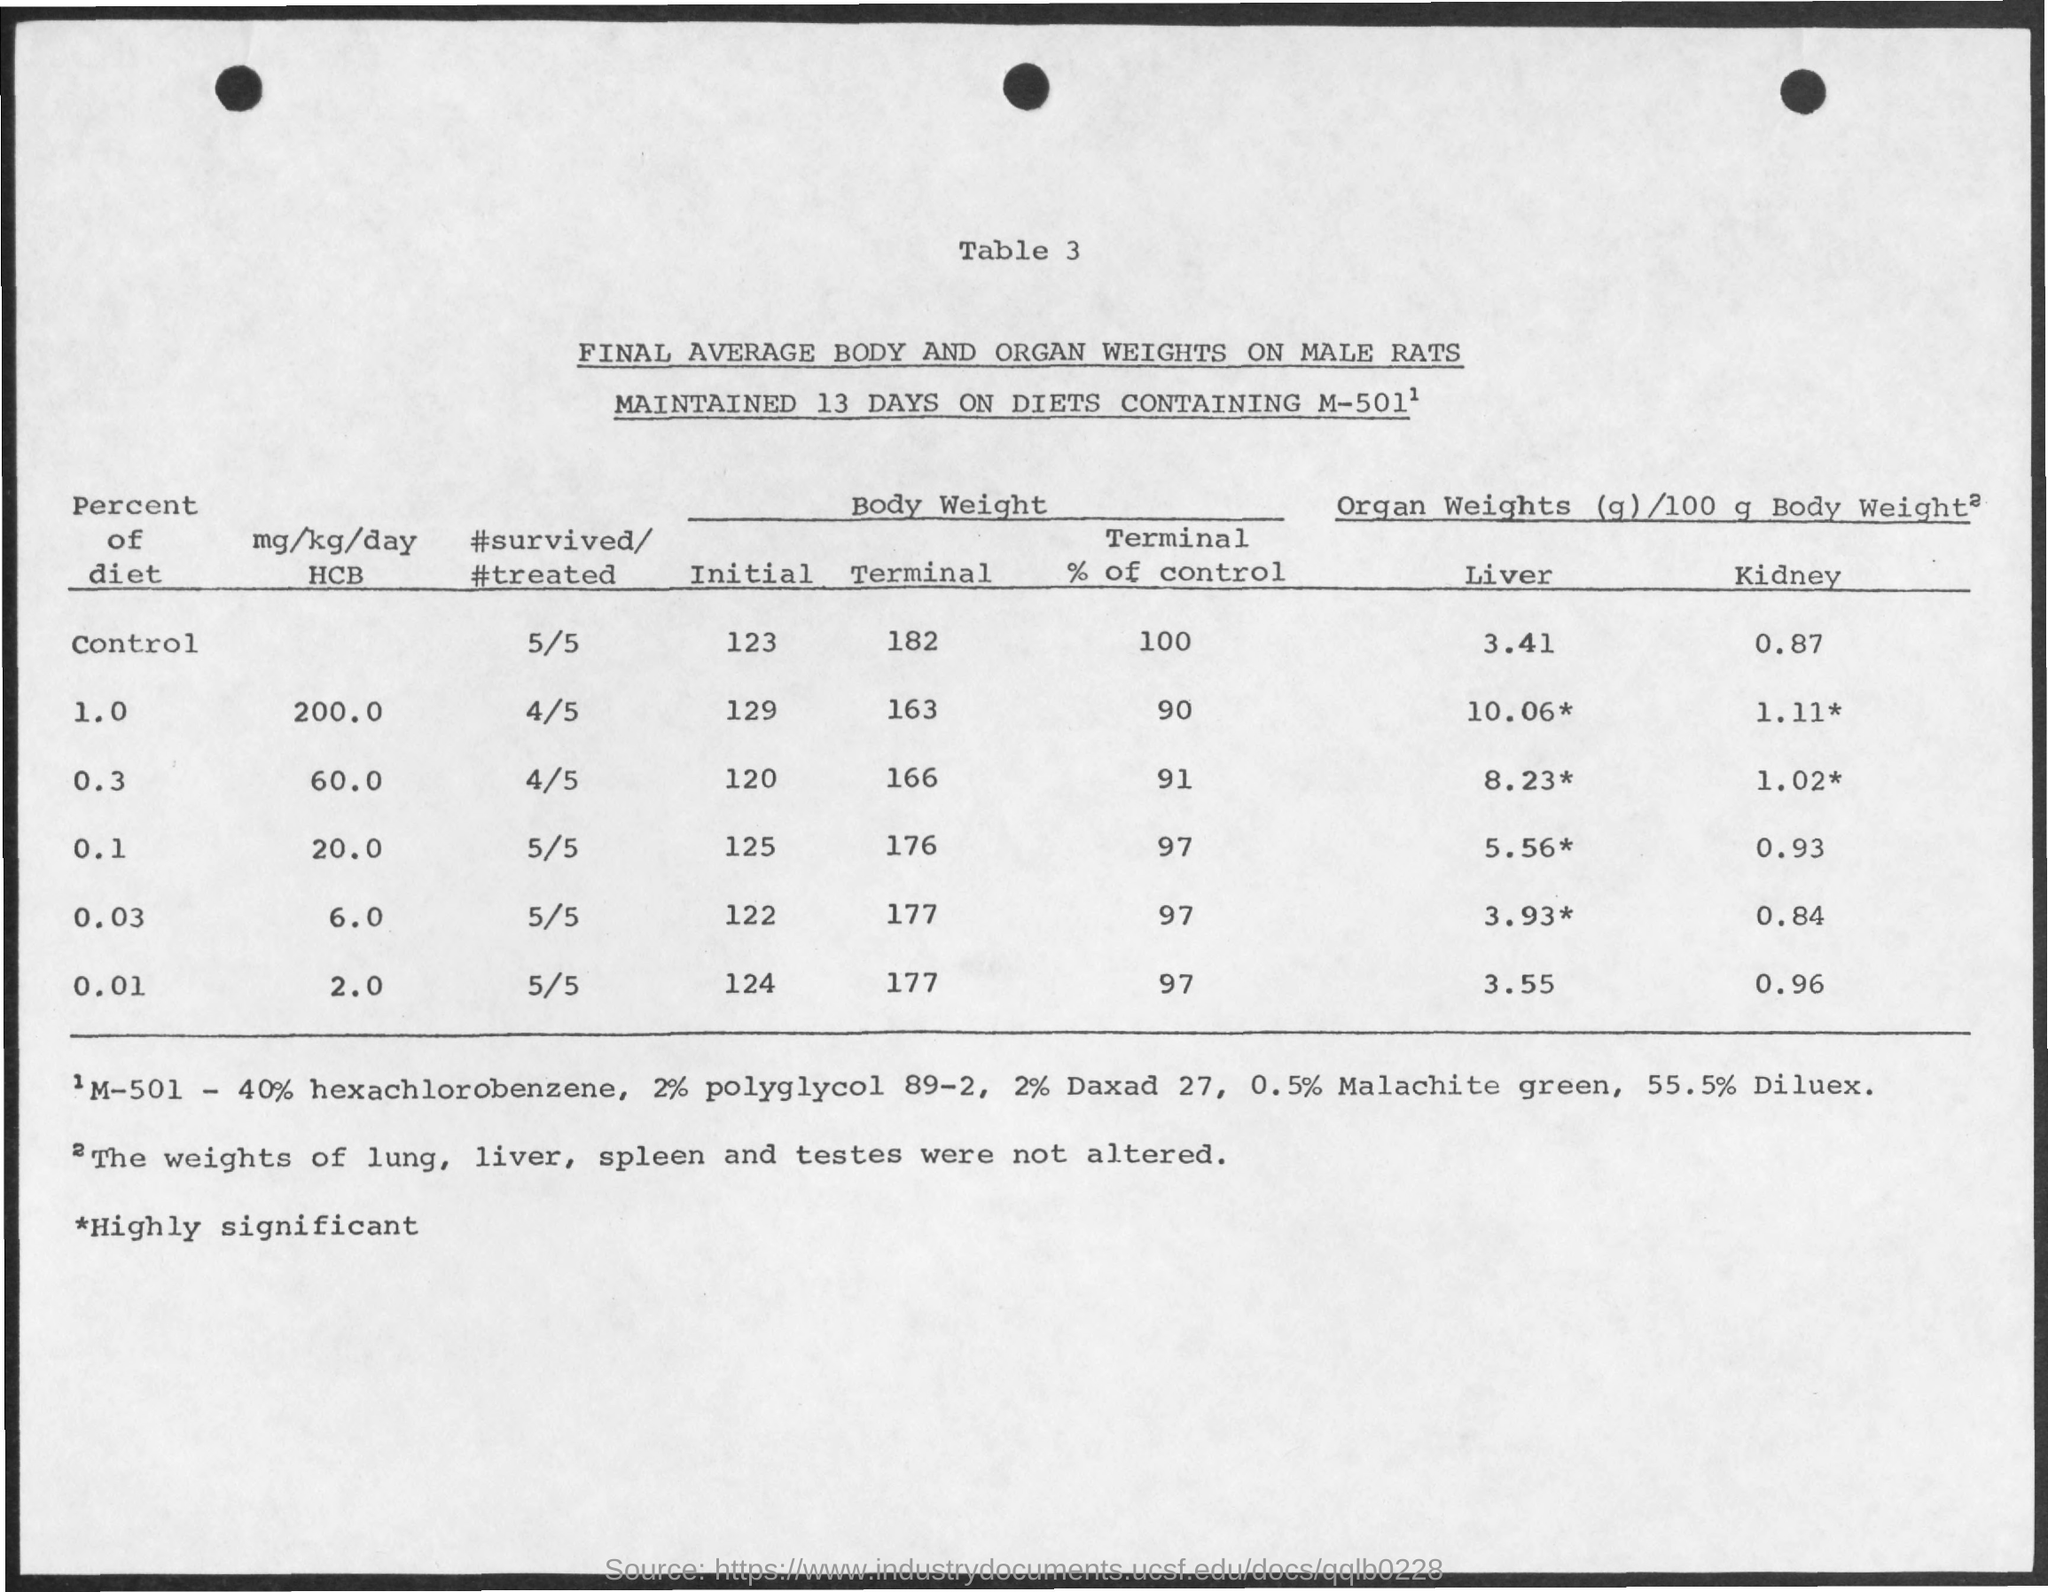What is the table number?
Offer a very short reply. 3. 